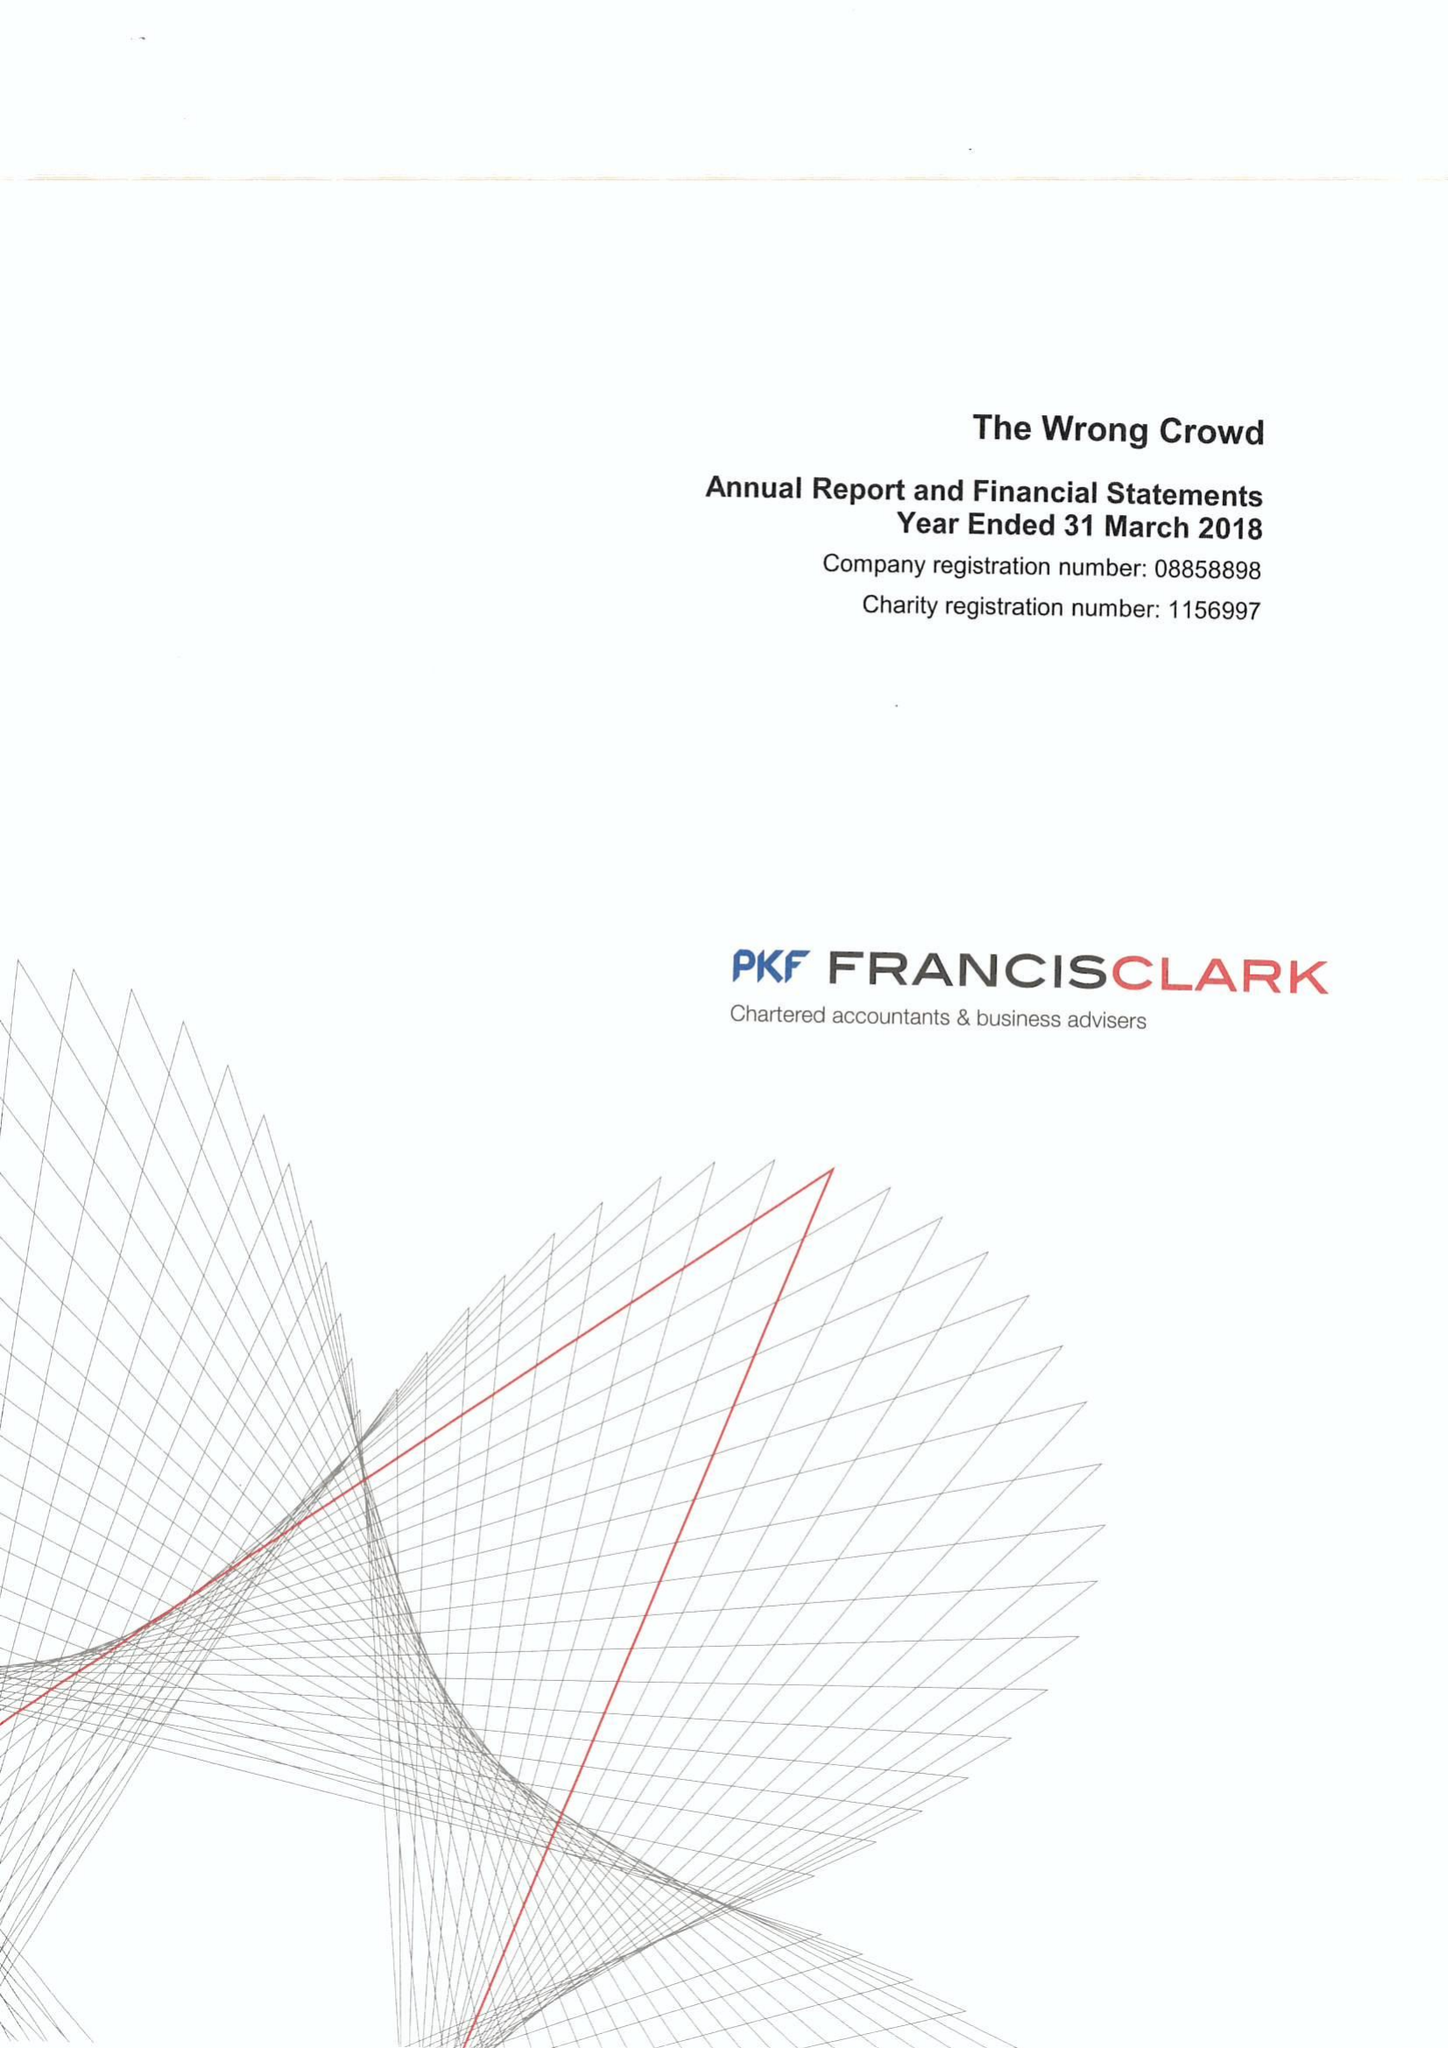What is the value for the address__postcode?
Answer the question using a single word or phrase. TQ9 6JG 